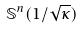<formula> <loc_0><loc_0><loc_500><loc_500>\mathbb { S } ^ { n } ( 1 / \sqrt { \kappa } )</formula> 